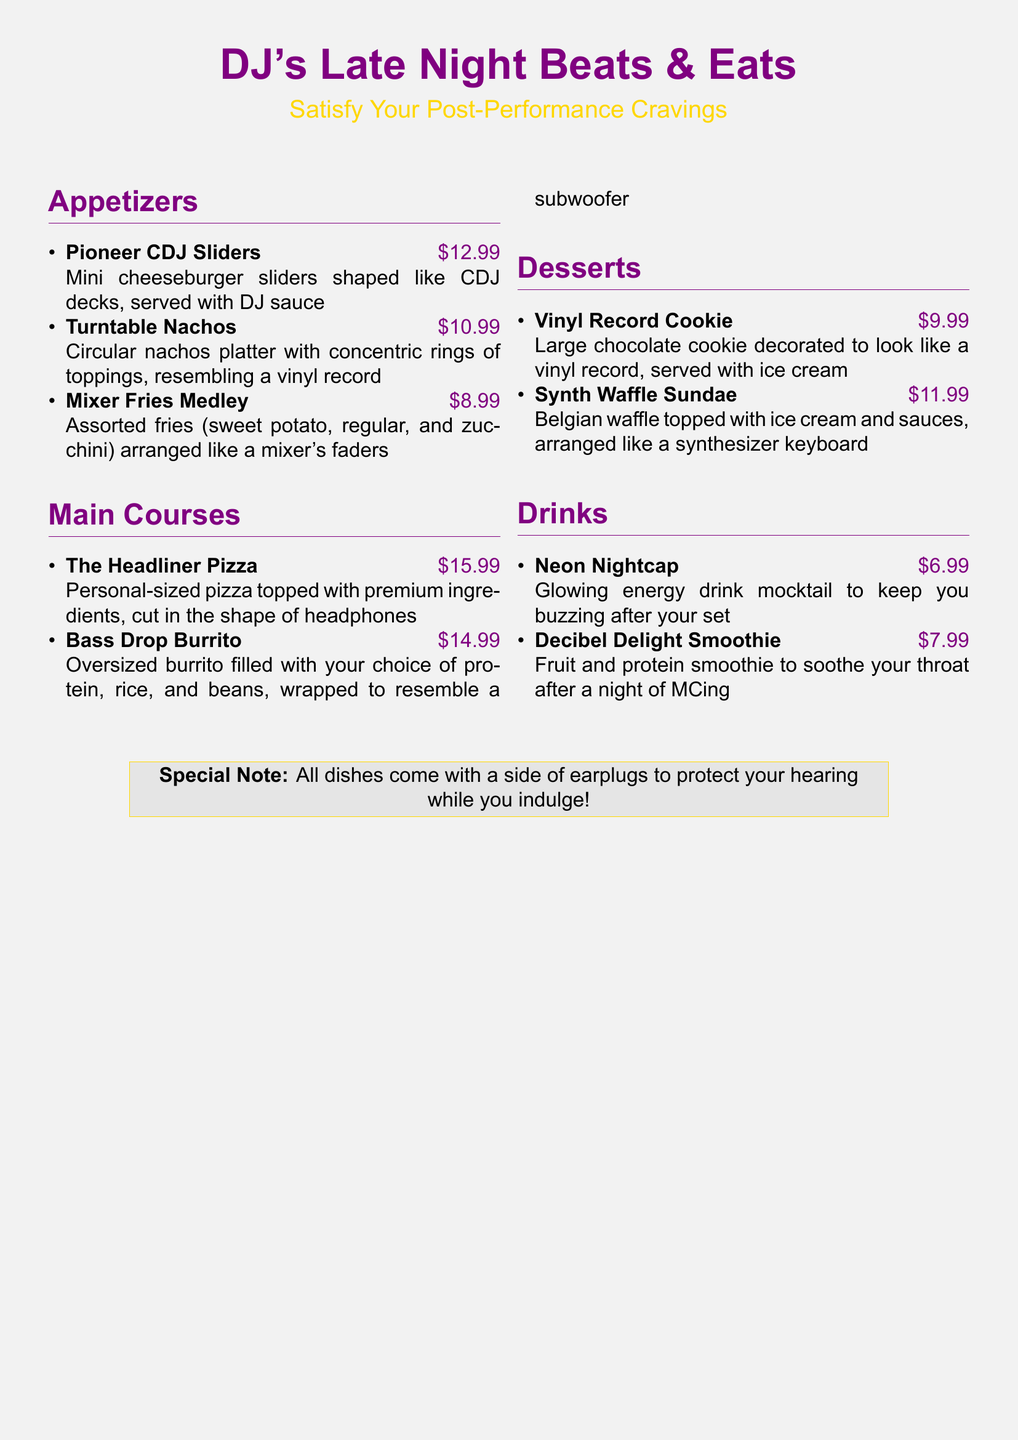What is the price of Pioneer CDJ Sliders? The price of Pioneer CDJ Sliders is listed in the document as $12.99.
Answer: $12.99 What dessert is shaped like a vinyl record? The dessert that resembles a vinyl record is the Vinyl Record Cookie.
Answer: Vinyl Record Cookie How many types of fries are included in the Mixer Fries Medley? The Mixer Fries Medley includes three types of fries: sweet potato, regular, and zucchini.
Answer: Three What is the highest-priced item on the menu? The highest-priced item can be determined by comparing the prices, which shows The Headliner Pizza at $15.99.
Answer: The Headliner Pizza Which drink is an energy drink mocktail? The drink described as a glowing energy drink mocktail is the Neon Nightcap.
Answer: Neon Nightcap What is served with all dishes? The document states that all dishes come with a side of earplugs to protect your hearing.
Answer: Earplugs What shape is the Bass Drop Burrito wrapped in? The Bass Drop Burrito is wrapped to resemble a subwoofer, as mentioned in the description.
Answer: Subwoofer What course features products shaped like musical equipment? The appetizers feature products shaped like musical equipment, including items like Pioneer CDJ Sliders and Mixer Fries Medley.
Answer: Appetizers 